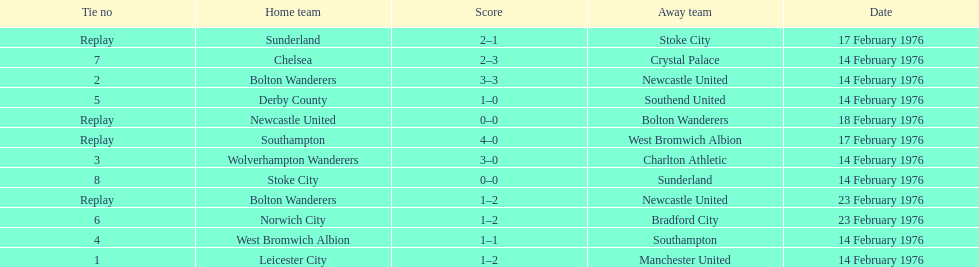How many games played by sunderland are listed here? 2. 